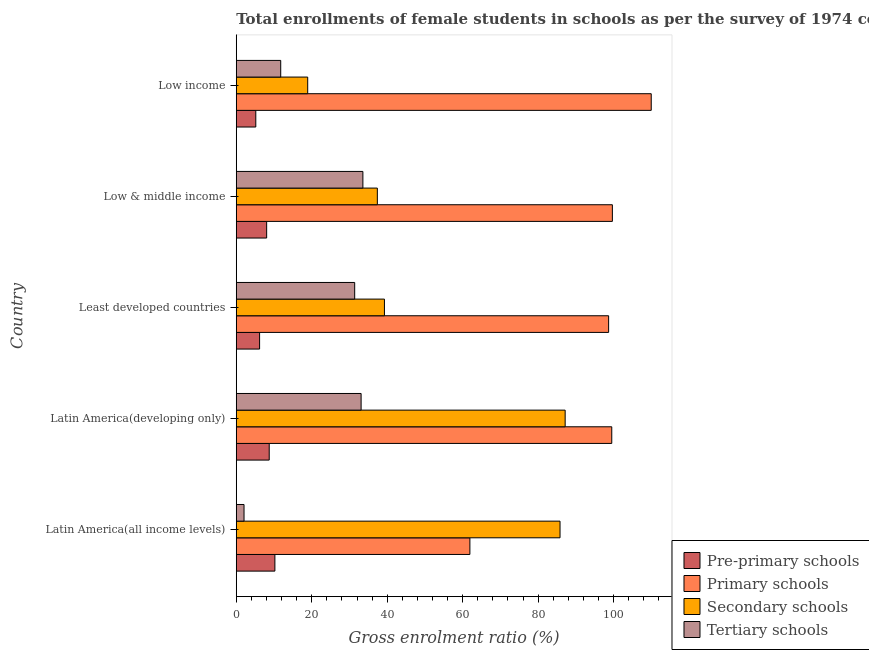How many groups of bars are there?
Provide a short and direct response. 5. Are the number of bars per tick equal to the number of legend labels?
Your answer should be compact. Yes. How many bars are there on the 3rd tick from the top?
Make the answer very short. 4. How many bars are there on the 1st tick from the bottom?
Your response must be concise. 4. What is the label of the 3rd group of bars from the top?
Your answer should be very brief. Least developed countries. In how many cases, is the number of bars for a given country not equal to the number of legend labels?
Ensure brevity in your answer.  0. What is the gross enrolment ratio(female) in tertiary schools in Low income?
Provide a short and direct response. 11.78. Across all countries, what is the maximum gross enrolment ratio(female) in tertiary schools?
Offer a very short reply. 33.55. Across all countries, what is the minimum gross enrolment ratio(female) in primary schools?
Offer a terse response. 61.9. In which country was the gross enrolment ratio(female) in tertiary schools maximum?
Give a very brief answer. Low & middle income. What is the total gross enrolment ratio(female) in primary schools in the graph?
Keep it short and to the point. 469.68. What is the difference between the gross enrolment ratio(female) in primary schools in Latin America(all income levels) and that in Latin America(developing only)?
Give a very brief answer. -37.59. What is the difference between the gross enrolment ratio(female) in primary schools in Low & middle income and the gross enrolment ratio(female) in pre-primary schools in Least developed countries?
Your answer should be compact. 93.48. What is the average gross enrolment ratio(female) in primary schools per country?
Offer a very short reply. 93.94. What is the difference between the gross enrolment ratio(female) in primary schools and gross enrolment ratio(female) in secondary schools in Low & middle income?
Your response must be concise. 62.28. What is the ratio of the gross enrolment ratio(female) in secondary schools in Latin America(developing only) to that in Low income?
Make the answer very short. 4.6. What is the difference between the highest and the second highest gross enrolment ratio(female) in pre-primary schools?
Make the answer very short. 1.5. What is the difference between the highest and the lowest gross enrolment ratio(female) in primary schools?
Your response must be concise. 48.05. In how many countries, is the gross enrolment ratio(female) in tertiary schools greater than the average gross enrolment ratio(female) in tertiary schools taken over all countries?
Make the answer very short. 3. What does the 3rd bar from the top in Latin America(developing only) represents?
Ensure brevity in your answer.  Primary schools. What does the 3rd bar from the bottom in Latin America(all income levels) represents?
Offer a terse response. Secondary schools. How many bars are there?
Offer a very short reply. 20. Are all the bars in the graph horizontal?
Your response must be concise. Yes. Does the graph contain grids?
Provide a succinct answer. No. Where does the legend appear in the graph?
Keep it short and to the point. Bottom right. How are the legend labels stacked?
Give a very brief answer. Vertical. What is the title of the graph?
Your answer should be compact. Total enrollments of female students in schools as per the survey of 1974 conducted in different countries. Does "WFP" appear as one of the legend labels in the graph?
Give a very brief answer. No. What is the label or title of the X-axis?
Ensure brevity in your answer.  Gross enrolment ratio (%). What is the label or title of the Y-axis?
Give a very brief answer. Country. What is the Gross enrolment ratio (%) in Pre-primary schools in Latin America(all income levels)?
Make the answer very short. 10.24. What is the Gross enrolment ratio (%) of Primary schools in Latin America(all income levels)?
Your answer should be compact. 61.9. What is the Gross enrolment ratio (%) in Secondary schools in Latin America(all income levels)?
Your answer should be very brief. 85.79. What is the Gross enrolment ratio (%) in Tertiary schools in Latin America(all income levels)?
Keep it short and to the point. 2.06. What is the Gross enrolment ratio (%) of Pre-primary schools in Latin America(developing only)?
Provide a succinct answer. 8.74. What is the Gross enrolment ratio (%) in Primary schools in Latin America(developing only)?
Provide a short and direct response. 99.5. What is the Gross enrolment ratio (%) of Secondary schools in Latin America(developing only)?
Give a very brief answer. 87.15. What is the Gross enrolment ratio (%) of Tertiary schools in Latin America(developing only)?
Your answer should be compact. 33.08. What is the Gross enrolment ratio (%) in Pre-primary schools in Least developed countries?
Ensure brevity in your answer.  6.18. What is the Gross enrolment ratio (%) of Primary schools in Least developed countries?
Keep it short and to the point. 98.67. What is the Gross enrolment ratio (%) in Secondary schools in Least developed countries?
Offer a terse response. 39.26. What is the Gross enrolment ratio (%) of Tertiary schools in Least developed countries?
Offer a very short reply. 31.38. What is the Gross enrolment ratio (%) in Pre-primary schools in Low & middle income?
Keep it short and to the point. 8.06. What is the Gross enrolment ratio (%) of Primary schools in Low & middle income?
Offer a very short reply. 99.66. What is the Gross enrolment ratio (%) in Secondary schools in Low & middle income?
Your answer should be compact. 37.38. What is the Gross enrolment ratio (%) in Tertiary schools in Low & middle income?
Give a very brief answer. 33.55. What is the Gross enrolment ratio (%) of Pre-primary schools in Low income?
Offer a very short reply. 5.18. What is the Gross enrolment ratio (%) in Primary schools in Low income?
Keep it short and to the point. 109.95. What is the Gross enrolment ratio (%) in Secondary schools in Low income?
Provide a succinct answer. 18.93. What is the Gross enrolment ratio (%) of Tertiary schools in Low income?
Ensure brevity in your answer.  11.78. Across all countries, what is the maximum Gross enrolment ratio (%) in Pre-primary schools?
Your answer should be very brief. 10.24. Across all countries, what is the maximum Gross enrolment ratio (%) in Primary schools?
Your answer should be compact. 109.95. Across all countries, what is the maximum Gross enrolment ratio (%) in Secondary schools?
Offer a very short reply. 87.15. Across all countries, what is the maximum Gross enrolment ratio (%) of Tertiary schools?
Provide a short and direct response. 33.55. Across all countries, what is the minimum Gross enrolment ratio (%) of Pre-primary schools?
Keep it short and to the point. 5.18. Across all countries, what is the minimum Gross enrolment ratio (%) of Primary schools?
Your answer should be very brief. 61.9. Across all countries, what is the minimum Gross enrolment ratio (%) of Secondary schools?
Your answer should be very brief. 18.93. Across all countries, what is the minimum Gross enrolment ratio (%) of Tertiary schools?
Your answer should be compact. 2.06. What is the total Gross enrolment ratio (%) of Pre-primary schools in the graph?
Make the answer very short. 38.39. What is the total Gross enrolment ratio (%) in Primary schools in the graph?
Make the answer very short. 469.68. What is the total Gross enrolment ratio (%) in Secondary schools in the graph?
Offer a very short reply. 268.52. What is the total Gross enrolment ratio (%) of Tertiary schools in the graph?
Keep it short and to the point. 111.86. What is the difference between the Gross enrolment ratio (%) in Pre-primary schools in Latin America(all income levels) and that in Latin America(developing only)?
Offer a terse response. 1.5. What is the difference between the Gross enrolment ratio (%) in Primary schools in Latin America(all income levels) and that in Latin America(developing only)?
Your answer should be compact. -37.59. What is the difference between the Gross enrolment ratio (%) in Secondary schools in Latin America(all income levels) and that in Latin America(developing only)?
Provide a short and direct response. -1.36. What is the difference between the Gross enrolment ratio (%) of Tertiary schools in Latin America(all income levels) and that in Latin America(developing only)?
Ensure brevity in your answer.  -31.02. What is the difference between the Gross enrolment ratio (%) in Pre-primary schools in Latin America(all income levels) and that in Least developed countries?
Provide a short and direct response. 4.05. What is the difference between the Gross enrolment ratio (%) in Primary schools in Latin America(all income levels) and that in Least developed countries?
Offer a very short reply. -36.76. What is the difference between the Gross enrolment ratio (%) of Secondary schools in Latin America(all income levels) and that in Least developed countries?
Give a very brief answer. 46.52. What is the difference between the Gross enrolment ratio (%) of Tertiary schools in Latin America(all income levels) and that in Least developed countries?
Keep it short and to the point. -29.32. What is the difference between the Gross enrolment ratio (%) of Pre-primary schools in Latin America(all income levels) and that in Low & middle income?
Provide a short and direct response. 2.18. What is the difference between the Gross enrolment ratio (%) of Primary schools in Latin America(all income levels) and that in Low & middle income?
Your answer should be very brief. -37.76. What is the difference between the Gross enrolment ratio (%) of Secondary schools in Latin America(all income levels) and that in Low & middle income?
Keep it short and to the point. 48.41. What is the difference between the Gross enrolment ratio (%) of Tertiary schools in Latin America(all income levels) and that in Low & middle income?
Keep it short and to the point. -31.49. What is the difference between the Gross enrolment ratio (%) in Pre-primary schools in Latin America(all income levels) and that in Low income?
Give a very brief answer. 5.06. What is the difference between the Gross enrolment ratio (%) of Primary schools in Latin America(all income levels) and that in Low income?
Keep it short and to the point. -48.05. What is the difference between the Gross enrolment ratio (%) in Secondary schools in Latin America(all income levels) and that in Low income?
Keep it short and to the point. 66.86. What is the difference between the Gross enrolment ratio (%) of Tertiary schools in Latin America(all income levels) and that in Low income?
Your response must be concise. -9.72. What is the difference between the Gross enrolment ratio (%) of Pre-primary schools in Latin America(developing only) and that in Least developed countries?
Make the answer very short. 2.55. What is the difference between the Gross enrolment ratio (%) of Primary schools in Latin America(developing only) and that in Least developed countries?
Your answer should be very brief. 0.83. What is the difference between the Gross enrolment ratio (%) in Secondary schools in Latin America(developing only) and that in Least developed countries?
Keep it short and to the point. 47.89. What is the difference between the Gross enrolment ratio (%) of Tertiary schools in Latin America(developing only) and that in Least developed countries?
Provide a succinct answer. 1.7. What is the difference between the Gross enrolment ratio (%) of Pre-primary schools in Latin America(developing only) and that in Low & middle income?
Provide a succinct answer. 0.68. What is the difference between the Gross enrolment ratio (%) in Primary schools in Latin America(developing only) and that in Low & middle income?
Your answer should be compact. -0.16. What is the difference between the Gross enrolment ratio (%) of Secondary schools in Latin America(developing only) and that in Low & middle income?
Offer a very short reply. 49.77. What is the difference between the Gross enrolment ratio (%) in Tertiary schools in Latin America(developing only) and that in Low & middle income?
Your answer should be compact. -0.47. What is the difference between the Gross enrolment ratio (%) in Pre-primary schools in Latin America(developing only) and that in Low income?
Offer a very short reply. 3.56. What is the difference between the Gross enrolment ratio (%) of Primary schools in Latin America(developing only) and that in Low income?
Provide a succinct answer. -10.45. What is the difference between the Gross enrolment ratio (%) of Secondary schools in Latin America(developing only) and that in Low income?
Provide a short and direct response. 68.22. What is the difference between the Gross enrolment ratio (%) of Tertiary schools in Latin America(developing only) and that in Low income?
Provide a succinct answer. 21.3. What is the difference between the Gross enrolment ratio (%) of Pre-primary schools in Least developed countries and that in Low & middle income?
Ensure brevity in your answer.  -1.87. What is the difference between the Gross enrolment ratio (%) in Primary schools in Least developed countries and that in Low & middle income?
Provide a short and direct response. -1. What is the difference between the Gross enrolment ratio (%) in Secondary schools in Least developed countries and that in Low & middle income?
Ensure brevity in your answer.  1.88. What is the difference between the Gross enrolment ratio (%) of Tertiary schools in Least developed countries and that in Low & middle income?
Ensure brevity in your answer.  -2.17. What is the difference between the Gross enrolment ratio (%) in Pre-primary schools in Least developed countries and that in Low income?
Your response must be concise. 1.01. What is the difference between the Gross enrolment ratio (%) of Primary schools in Least developed countries and that in Low income?
Make the answer very short. -11.29. What is the difference between the Gross enrolment ratio (%) of Secondary schools in Least developed countries and that in Low income?
Offer a terse response. 20.33. What is the difference between the Gross enrolment ratio (%) of Tertiary schools in Least developed countries and that in Low income?
Give a very brief answer. 19.6. What is the difference between the Gross enrolment ratio (%) of Pre-primary schools in Low & middle income and that in Low income?
Offer a terse response. 2.88. What is the difference between the Gross enrolment ratio (%) in Primary schools in Low & middle income and that in Low income?
Your answer should be compact. -10.29. What is the difference between the Gross enrolment ratio (%) in Secondary schools in Low & middle income and that in Low income?
Make the answer very short. 18.45. What is the difference between the Gross enrolment ratio (%) in Tertiary schools in Low & middle income and that in Low income?
Ensure brevity in your answer.  21.77. What is the difference between the Gross enrolment ratio (%) in Pre-primary schools in Latin America(all income levels) and the Gross enrolment ratio (%) in Primary schools in Latin America(developing only)?
Ensure brevity in your answer.  -89.26. What is the difference between the Gross enrolment ratio (%) of Pre-primary schools in Latin America(all income levels) and the Gross enrolment ratio (%) of Secondary schools in Latin America(developing only)?
Your answer should be very brief. -76.91. What is the difference between the Gross enrolment ratio (%) of Pre-primary schools in Latin America(all income levels) and the Gross enrolment ratio (%) of Tertiary schools in Latin America(developing only)?
Offer a very short reply. -22.85. What is the difference between the Gross enrolment ratio (%) of Primary schools in Latin America(all income levels) and the Gross enrolment ratio (%) of Secondary schools in Latin America(developing only)?
Give a very brief answer. -25.25. What is the difference between the Gross enrolment ratio (%) in Primary schools in Latin America(all income levels) and the Gross enrolment ratio (%) in Tertiary schools in Latin America(developing only)?
Make the answer very short. 28.82. What is the difference between the Gross enrolment ratio (%) of Secondary schools in Latin America(all income levels) and the Gross enrolment ratio (%) of Tertiary schools in Latin America(developing only)?
Your response must be concise. 52.71. What is the difference between the Gross enrolment ratio (%) in Pre-primary schools in Latin America(all income levels) and the Gross enrolment ratio (%) in Primary schools in Least developed countries?
Give a very brief answer. -88.43. What is the difference between the Gross enrolment ratio (%) in Pre-primary schools in Latin America(all income levels) and the Gross enrolment ratio (%) in Secondary schools in Least developed countries?
Keep it short and to the point. -29.03. What is the difference between the Gross enrolment ratio (%) in Pre-primary schools in Latin America(all income levels) and the Gross enrolment ratio (%) in Tertiary schools in Least developed countries?
Keep it short and to the point. -21.15. What is the difference between the Gross enrolment ratio (%) of Primary schools in Latin America(all income levels) and the Gross enrolment ratio (%) of Secondary schools in Least developed countries?
Your answer should be compact. 22.64. What is the difference between the Gross enrolment ratio (%) of Primary schools in Latin America(all income levels) and the Gross enrolment ratio (%) of Tertiary schools in Least developed countries?
Offer a terse response. 30.52. What is the difference between the Gross enrolment ratio (%) of Secondary schools in Latin America(all income levels) and the Gross enrolment ratio (%) of Tertiary schools in Least developed countries?
Provide a succinct answer. 54.41. What is the difference between the Gross enrolment ratio (%) in Pre-primary schools in Latin America(all income levels) and the Gross enrolment ratio (%) in Primary schools in Low & middle income?
Give a very brief answer. -89.42. What is the difference between the Gross enrolment ratio (%) of Pre-primary schools in Latin America(all income levels) and the Gross enrolment ratio (%) of Secondary schools in Low & middle income?
Provide a succinct answer. -27.15. What is the difference between the Gross enrolment ratio (%) of Pre-primary schools in Latin America(all income levels) and the Gross enrolment ratio (%) of Tertiary schools in Low & middle income?
Make the answer very short. -23.32. What is the difference between the Gross enrolment ratio (%) in Primary schools in Latin America(all income levels) and the Gross enrolment ratio (%) in Secondary schools in Low & middle income?
Your answer should be compact. 24.52. What is the difference between the Gross enrolment ratio (%) in Primary schools in Latin America(all income levels) and the Gross enrolment ratio (%) in Tertiary schools in Low & middle income?
Provide a succinct answer. 28.35. What is the difference between the Gross enrolment ratio (%) in Secondary schools in Latin America(all income levels) and the Gross enrolment ratio (%) in Tertiary schools in Low & middle income?
Provide a succinct answer. 52.23. What is the difference between the Gross enrolment ratio (%) of Pre-primary schools in Latin America(all income levels) and the Gross enrolment ratio (%) of Primary schools in Low income?
Offer a terse response. -99.72. What is the difference between the Gross enrolment ratio (%) in Pre-primary schools in Latin America(all income levels) and the Gross enrolment ratio (%) in Secondary schools in Low income?
Keep it short and to the point. -8.7. What is the difference between the Gross enrolment ratio (%) in Pre-primary schools in Latin America(all income levels) and the Gross enrolment ratio (%) in Tertiary schools in Low income?
Your response must be concise. -1.55. What is the difference between the Gross enrolment ratio (%) in Primary schools in Latin America(all income levels) and the Gross enrolment ratio (%) in Secondary schools in Low income?
Keep it short and to the point. 42.97. What is the difference between the Gross enrolment ratio (%) in Primary schools in Latin America(all income levels) and the Gross enrolment ratio (%) in Tertiary schools in Low income?
Give a very brief answer. 50.12. What is the difference between the Gross enrolment ratio (%) in Secondary schools in Latin America(all income levels) and the Gross enrolment ratio (%) in Tertiary schools in Low income?
Offer a very short reply. 74.01. What is the difference between the Gross enrolment ratio (%) in Pre-primary schools in Latin America(developing only) and the Gross enrolment ratio (%) in Primary schools in Least developed countries?
Keep it short and to the point. -89.93. What is the difference between the Gross enrolment ratio (%) of Pre-primary schools in Latin America(developing only) and the Gross enrolment ratio (%) of Secondary schools in Least developed countries?
Your answer should be very brief. -30.53. What is the difference between the Gross enrolment ratio (%) in Pre-primary schools in Latin America(developing only) and the Gross enrolment ratio (%) in Tertiary schools in Least developed countries?
Your response must be concise. -22.65. What is the difference between the Gross enrolment ratio (%) in Primary schools in Latin America(developing only) and the Gross enrolment ratio (%) in Secondary schools in Least developed countries?
Provide a short and direct response. 60.24. What is the difference between the Gross enrolment ratio (%) in Primary schools in Latin America(developing only) and the Gross enrolment ratio (%) in Tertiary schools in Least developed countries?
Keep it short and to the point. 68.12. What is the difference between the Gross enrolment ratio (%) in Secondary schools in Latin America(developing only) and the Gross enrolment ratio (%) in Tertiary schools in Least developed countries?
Provide a short and direct response. 55.77. What is the difference between the Gross enrolment ratio (%) of Pre-primary schools in Latin America(developing only) and the Gross enrolment ratio (%) of Primary schools in Low & middle income?
Your answer should be very brief. -90.92. What is the difference between the Gross enrolment ratio (%) in Pre-primary schools in Latin America(developing only) and the Gross enrolment ratio (%) in Secondary schools in Low & middle income?
Give a very brief answer. -28.65. What is the difference between the Gross enrolment ratio (%) of Pre-primary schools in Latin America(developing only) and the Gross enrolment ratio (%) of Tertiary schools in Low & middle income?
Give a very brief answer. -24.82. What is the difference between the Gross enrolment ratio (%) in Primary schools in Latin America(developing only) and the Gross enrolment ratio (%) in Secondary schools in Low & middle income?
Keep it short and to the point. 62.12. What is the difference between the Gross enrolment ratio (%) in Primary schools in Latin America(developing only) and the Gross enrolment ratio (%) in Tertiary schools in Low & middle income?
Give a very brief answer. 65.94. What is the difference between the Gross enrolment ratio (%) in Secondary schools in Latin America(developing only) and the Gross enrolment ratio (%) in Tertiary schools in Low & middle income?
Give a very brief answer. 53.59. What is the difference between the Gross enrolment ratio (%) in Pre-primary schools in Latin America(developing only) and the Gross enrolment ratio (%) in Primary schools in Low income?
Keep it short and to the point. -101.22. What is the difference between the Gross enrolment ratio (%) in Pre-primary schools in Latin America(developing only) and the Gross enrolment ratio (%) in Secondary schools in Low income?
Provide a succinct answer. -10.2. What is the difference between the Gross enrolment ratio (%) in Pre-primary schools in Latin America(developing only) and the Gross enrolment ratio (%) in Tertiary schools in Low income?
Ensure brevity in your answer.  -3.04. What is the difference between the Gross enrolment ratio (%) of Primary schools in Latin America(developing only) and the Gross enrolment ratio (%) of Secondary schools in Low income?
Provide a short and direct response. 80.57. What is the difference between the Gross enrolment ratio (%) of Primary schools in Latin America(developing only) and the Gross enrolment ratio (%) of Tertiary schools in Low income?
Make the answer very short. 87.72. What is the difference between the Gross enrolment ratio (%) in Secondary schools in Latin America(developing only) and the Gross enrolment ratio (%) in Tertiary schools in Low income?
Your response must be concise. 75.37. What is the difference between the Gross enrolment ratio (%) in Pre-primary schools in Least developed countries and the Gross enrolment ratio (%) in Primary schools in Low & middle income?
Give a very brief answer. -93.48. What is the difference between the Gross enrolment ratio (%) in Pre-primary schools in Least developed countries and the Gross enrolment ratio (%) in Secondary schools in Low & middle income?
Your response must be concise. -31.2. What is the difference between the Gross enrolment ratio (%) in Pre-primary schools in Least developed countries and the Gross enrolment ratio (%) in Tertiary schools in Low & middle income?
Your response must be concise. -27.37. What is the difference between the Gross enrolment ratio (%) of Primary schools in Least developed countries and the Gross enrolment ratio (%) of Secondary schools in Low & middle income?
Your response must be concise. 61.28. What is the difference between the Gross enrolment ratio (%) in Primary schools in Least developed countries and the Gross enrolment ratio (%) in Tertiary schools in Low & middle income?
Ensure brevity in your answer.  65.11. What is the difference between the Gross enrolment ratio (%) of Secondary schools in Least developed countries and the Gross enrolment ratio (%) of Tertiary schools in Low & middle income?
Your answer should be very brief. 5.71. What is the difference between the Gross enrolment ratio (%) in Pre-primary schools in Least developed countries and the Gross enrolment ratio (%) in Primary schools in Low income?
Give a very brief answer. -103.77. What is the difference between the Gross enrolment ratio (%) of Pre-primary schools in Least developed countries and the Gross enrolment ratio (%) of Secondary schools in Low income?
Your answer should be compact. -12.75. What is the difference between the Gross enrolment ratio (%) of Pre-primary schools in Least developed countries and the Gross enrolment ratio (%) of Tertiary schools in Low income?
Make the answer very short. -5.6. What is the difference between the Gross enrolment ratio (%) of Primary schools in Least developed countries and the Gross enrolment ratio (%) of Secondary schools in Low income?
Keep it short and to the point. 79.73. What is the difference between the Gross enrolment ratio (%) of Primary schools in Least developed countries and the Gross enrolment ratio (%) of Tertiary schools in Low income?
Ensure brevity in your answer.  86.88. What is the difference between the Gross enrolment ratio (%) of Secondary schools in Least developed countries and the Gross enrolment ratio (%) of Tertiary schools in Low income?
Your response must be concise. 27.48. What is the difference between the Gross enrolment ratio (%) in Pre-primary schools in Low & middle income and the Gross enrolment ratio (%) in Primary schools in Low income?
Your response must be concise. -101.9. What is the difference between the Gross enrolment ratio (%) in Pre-primary schools in Low & middle income and the Gross enrolment ratio (%) in Secondary schools in Low income?
Offer a terse response. -10.88. What is the difference between the Gross enrolment ratio (%) in Pre-primary schools in Low & middle income and the Gross enrolment ratio (%) in Tertiary schools in Low income?
Keep it short and to the point. -3.72. What is the difference between the Gross enrolment ratio (%) in Primary schools in Low & middle income and the Gross enrolment ratio (%) in Secondary schools in Low income?
Make the answer very short. 80.73. What is the difference between the Gross enrolment ratio (%) in Primary schools in Low & middle income and the Gross enrolment ratio (%) in Tertiary schools in Low income?
Your answer should be compact. 87.88. What is the difference between the Gross enrolment ratio (%) of Secondary schools in Low & middle income and the Gross enrolment ratio (%) of Tertiary schools in Low income?
Provide a succinct answer. 25.6. What is the average Gross enrolment ratio (%) in Pre-primary schools per country?
Offer a terse response. 7.68. What is the average Gross enrolment ratio (%) in Primary schools per country?
Offer a terse response. 93.94. What is the average Gross enrolment ratio (%) in Secondary schools per country?
Provide a short and direct response. 53.7. What is the average Gross enrolment ratio (%) of Tertiary schools per country?
Offer a terse response. 22.37. What is the difference between the Gross enrolment ratio (%) in Pre-primary schools and Gross enrolment ratio (%) in Primary schools in Latin America(all income levels)?
Your answer should be very brief. -51.67. What is the difference between the Gross enrolment ratio (%) in Pre-primary schools and Gross enrolment ratio (%) in Secondary schools in Latin America(all income levels)?
Give a very brief answer. -75.55. What is the difference between the Gross enrolment ratio (%) of Pre-primary schools and Gross enrolment ratio (%) of Tertiary schools in Latin America(all income levels)?
Offer a terse response. 8.18. What is the difference between the Gross enrolment ratio (%) in Primary schools and Gross enrolment ratio (%) in Secondary schools in Latin America(all income levels)?
Your response must be concise. -23.88. What is the difference between the Gross enrolment ratio (%) in Primary schools and Gross enrolment ratio (%) in Tertiary schools in Latin America(all income levels)?
Your answer should be compact. 59.84. What is the difference between the Gross enrolment ratio (%) of Secondary schools and Gross enrolment ratio (%) of Tertiary schools in Latin America(all income levels)?
Your response must be concise. 83.73. What is the difference between the Gross enrolment ratio (%) of Pre-primary schools and Gross enrolment ratio (%) of Primary schools in Latin America(developing only)?
Your answer should be compact. -90.76. What is the difference between the Gross enrolment ratio (%) of Pre-primary schools and Gross enrolment ratio (%) of Secondary schools in Latin America(developing only)?
Your answer should be very brief. -78.41. What is the difference between the Gross enrolment ratio (%) of Pre-primary schools and Gross enrolment ratio (%) of Tertiary schools in Latin America(developing only)?
Provide a short and direct response. -24.34. What is the difference between the Gross enrolment ratio (%) of Primary schools and Gross enrolment ratio (%) of Secondary schools in Latin America(developing only)?
Ensure brevity in your answer.  12.35. What is the difference between the Gross enrolment ratio (%) in Primary schools and Gross enrolment ratio (%) in Tertiary schools in Latin America(developing only)?
Give a very brief answer. 66.42. What is the difference between the Gross enrolment ratio (%) in Secondary schools and Gross enrolment ratio (%) in Tertiary schools in Latin America(developing only)?
Your answer should be compact. 54.07. What is the difference between the Gross enrolment ratio (%) of Pre-primary schools and Gross enrolment ratio (%) of Primary schools in Least developed countries?
Ensure brevity in your answer.  -92.48. What is the difference between the Gross enrolment ratio (%) of Pre-primary schools and Gross enrolment ratio (%) of Secondary schools in Least developed countries?
Offer a very short reply. -33.08. What is the difference between the Gross enrolment ratio (%) in Pre-primary schools and Gross enrolment ratio (%) in Tertiary schools in Least developed countries?
Provide a short and direct response. -25.2. What is the difference between the Gross enrolment ratio (%) in Primary schools and Gross enrolment ratio (%) in Secondary schools in Least developed countries?
Offer a very short reply. 59.4. What is the difference between the Gross enrolment ratio (%) in Primary schools and Gross enrolment ratio (%) in Tertiary schools in Least developed countries?
Provide a succinct answer. 67.28. What is the difference between the Gross enrolment ratio (%) in Secondary schools and Gross enrolment ratio (%) in Tertiary schools in Least developed countries?
Make the answer very short. 7.88. What is the difference between the Gross enrolment ratio (%) in Pre-primary schools and Gross enrolment ratio (%) in Primary schools in Low & middle income?
Your answer should be compact. -91.6. What is the difference between the Gross enrolment ratio (%) in Pre-primary schools and Gross enrolment ratio (%) in Secondary schools in Low & middle income?
Your answer should be very brief. -29.33. What is the difference between the Gross enrolment ratio (%) in Pre-primary schools and Gross enrolment ratio (%) in Tertiary schools in Low & middle income?
Give a very brief answer. -25.5. What is the difference between the Gross enrolment ratio (%) of Primary schools and Gross enrolment ratio (%) of Secondary schools in Low & middle income?
Make the answer very short. 62.28. What is the difference between the Gross enrolment ratio (%) in Primary schools and Gross enrolment ratio (%) in Tertiary schools in Low & middle income?
Your response must be concise. 66.11. What is the difference between the Gross enrolment ratio (%) in Secondary schools and Gross enrolment ratio (%) in Tertiary schools in Low & middle income?
Provide a succinct answer. 3.83. What is the difference between the Gross enrolment ratio (%) of Pre-primary schools and Gross enrolment ratio (%) of Primary schools in Low income?
Your answer should be very brief. -104.78. What is the difference between the Gross enrolment ratio (%) of Pre-primary schools and Gross enrolment ratio (%) of Secondary schools in Low income?
Offer a terse response. -13.75. What is the difference between the Gross enrolment ratio (%) of Pre-primary schools and Gross enrolment ratio (%) of Tertiary schools in Low income?
Provide a short and direct response. -6.6. What is the difference between the Gross enrolment ratio (%) in Primary schools and Gross enrolment ratio (%) in Secondary schools in Low income?
Keep it short and to the point. 91.02. What is the difference between the Gross enrolment ratio (%) in Primary schools and Gross enrolment ratio (%) in Tertiary schools in Low income?
Make the answer very short. 98.17. What is the difference between the Gross enrolment ratio (%) in Secondary schools and Gross enrolment ratio (%) in Tertiary schools in Low income?
Your answer should be compact. 7.15. What is the ratio of the Gross enrolment ratio (%) in Pre-primary schools in Latin America(all income levels) to that in Latin America(developing only)?
Your answer should be very brief. 1.17. What is the ratio of the Gross enrolment ratio (%) of Primary schools in Latin America(all income levels) to that in Latin America(developing only)?
Your answer should be very brief. 0.62. What is the ratio of the Gross enrolment ratio (%) of Secondary schools in Latin America(all income levels) to that in Latin America(developing only)?
Give a very brief answer. 0.98. What is the ratio of the Gross enrolment ratio (%) of Tertiary schools in Latin America(all income levels) to that in Latin America(developing only)?
Keep it short and to the point. 0.06. What is the ratio of the Gross enrolment ratio (%) in Pre-primary schools in Latin America(all income levels) to that in Least developed countries?
Keep it short and to the point. 1.66. What is the ratio of the Gross enrolment ratio (%) in Primary schools in Latin America(all income levels) to that in Least developed countries?
Your answer should be very brief. 0.63. What is the ratio of the Gross enrolment ratio (%) in Secondary schools in Latin America(all income levels) to that in Least developed countries?
Make the answer very short. 2.18. What is the ratio of the Gross enrolment ratio (%) of Tertiary schools in Latin America(all income levels) to that in Least developed countries?
Ensure brevity in your answer.  0.07. What is the ratio of the Gross enrolment ratio (%) in Pre-primary schools in Latin America(all income levels) to that in Low & middle income?
Keep it short and to the point. 1.27. What is the ratio of the Gross enrolment ratio (%) in Primary schools in Latin America(all income levels) to that in Low & middle income?
Provide a succinct answer. 0.62. What is the ratio of the Gross enrolment ratio (%) in Secondary schools in Latin America(all income levels) to that in Low & middle income?
Make the answer very short. 2.29. What is the ratio of the Gross enrolment ratio (%) in Tertiary schools in Latin America(all income levels) to that in Low & middle income?
Keep it short and to the point. 0.06. What is the ratio of the Gross enrolment ratio (%) in Pre-primary schools in Latin America(all income levels) to that in Low income?
Ensure brevity in your answer.  1.98. What is the ratio of the Gross enrolment ratio (%) in Primary schools in Latin America(all income levels) to that in Low income?
Your response must be concise. 0.56. What is the ratio of the Gross enrolment ratio (%) of Secondary schools in Latin America(all income levels) to that in Low income?
Offer a terse response. 4.53. What is the ratio of the Gross enrolment ratio (%) in Tertiary schools in Latin America(all income levels) to that in Low income?
Offer a terse response. 0.17. What is the ratio of the Gross enrolment ratio (%) of Pre-primary schools in Latin America(developing only) to that in Least developed countries?
Provide a succinct answer. 1.41. What is the ratio of the Gross enrolment ratio (%) in Primary schools in Latin America(developing only) to that in Least developed countries?
Your answer should be very brief. 1.01. What is the ratio of the Gross enrolment ratio (%) of Secondary schools in Latin America(developing only) to that in Least developed countries?
Give a very brief answer. 2.22. What is the ratio of the Gross enrolment ratio (%) of Tertiary schools in Latin America(developing only) to that in Least developed countries?
Offer a very short reply. 1.05. What is the ratio of the Gross enrolment ratio (%) in Pre-primary schools in Latin America(developing only) to that in Low & middle income?
Your answer should be compact. 1.08. What is the ratio of the Gross enrolment ratio (%) in Primary schools in Latin America(developing only) to that in Low & middle income?
Keep it short and to the point. 1. What is the ratio of the Gross enrolment ratio (%) in Secondary schools in Latin America(developing only) to that in Low & middle income?
Provide a short and direct response. 2.33. What is the ratio of the Gross enrolment ratio (%) of Tertiary schools in Latin America(developing only) to that in Low & middle income?
Offer a terse response. 0.99. What is the ratio of the Gross enrolment ratio (%) in Pre-primary schools in Latin America(developing only) to that in Low income?
Ensure brevity in your answer.  1.69. What is the ratio of the Gross enrolment ratio (%) of Primary schools in Latin America(developing only) to that in Low income?
Provide a short and direct response. 0.9. What is the ratio of the Gross enrolment ratio (%) of Secondary schools in Latin America(developing only) to that in Low income?
Keep it short and to the point. 4.6. What is the ratio of the Gross enrolment ratio (%) of Tertiary schools in Latin America(developing only) to that in Low income?
Ensure brevity in your answer.  2.81. What is the ratio of the Gross enrolment ratio (%) of Pre-primary schools in Least developed countries to that in Low & middle income?
Your answer should be compact. 0.77. What is the ratio of the Gross enrolment ratio (%) in Primary schools in Least developed countries to that in Low & middle income?
Make the answer very short. 0.99. What is the ratio of the Gross enrolment ratio (%) of Secondary schools in Least developed countries to that in Low & middle income?
Your answer should be very brief. 1.05. What is the ratio of the Gross enrolment ratio (%) in Tertiary schools in Least developed countries to that in Low & middle income?
Your answer should be compact. 0.94. What is the ratio of the Gross enrolment ratio (%) in Pre-primary schools in Least developed countries to that in Low income?
Ensure brevity in your answer.  1.19. What is the ratio of the Gross enrolment ratio (%) in Primary schools in Least developed countries to that in Low income?
Your answer should be compact. 0.9. What is the ratio of the Gross enrolment ratio (%) of Secondary schools in Least developed countries to that in Low income?
Make the answer very short. 2.07. What is the ratio of the Gross enrolment ratio (%) in Tertiary schools in Least developed countries to that in Low income?
Provide a short and direct response. 2.66. What is the ratio of the Gross enrolment ratio (%) of Pre-primary schools in Low & middle income to that in Low income?
Your response must be concise. 1.56. What is the ratio of the Gross enrolment ratio (%) in Primary schools in Low & middle income to that in Low income?
Provide a short and direct response. 0.91. What is the ratio of the Gross enrolment ratio (%) of Secondary schools in Low & middle income to that in Low income?
Provide a short and direct response. 1.97. What is the ratio of the Gross enrolment ratio (%) of Tertiary schools in Low & middle income to that in Low income?
Your answer should be very brief. 2.85. What is the difference between the highest and the second highest Gross enrolment ratio (%) in Pre-primary schools?
Provide a succinct answer. 1.5. What is the difference between the highest and the second highest Gross enrolment ratio (%) of Primary schools?
Keep it short and to the point. 10.29. What is the difference between the highest and the second highest Gross enrolment ratio (%) in Secondary schools?
Provide a short and direct response. 1.36. What is the difference between the highest and the second highest Gross enrolment ratio (%) in Tertiary schools?
Your answer should be very brief. 0.47. What is the difference between the highest and the lowest Gross enrolment ratio (%) of Pre-primary schools?
Provide a succinct answer. 5.06. What is the difference between the highest and the lowest Gross enrolment ratio (%) in Primary schools?
Your response must be concise. 48.05. What is the difference between the highest and the lowest Gross enrolment ratio (%) of Secondary schools?
Your answer should be compact. 68.22. What is the difference between the highest and the lowest Gross enrolment ratio (%) in Tertiary schools?
Give a very brief answer. 31.49. 